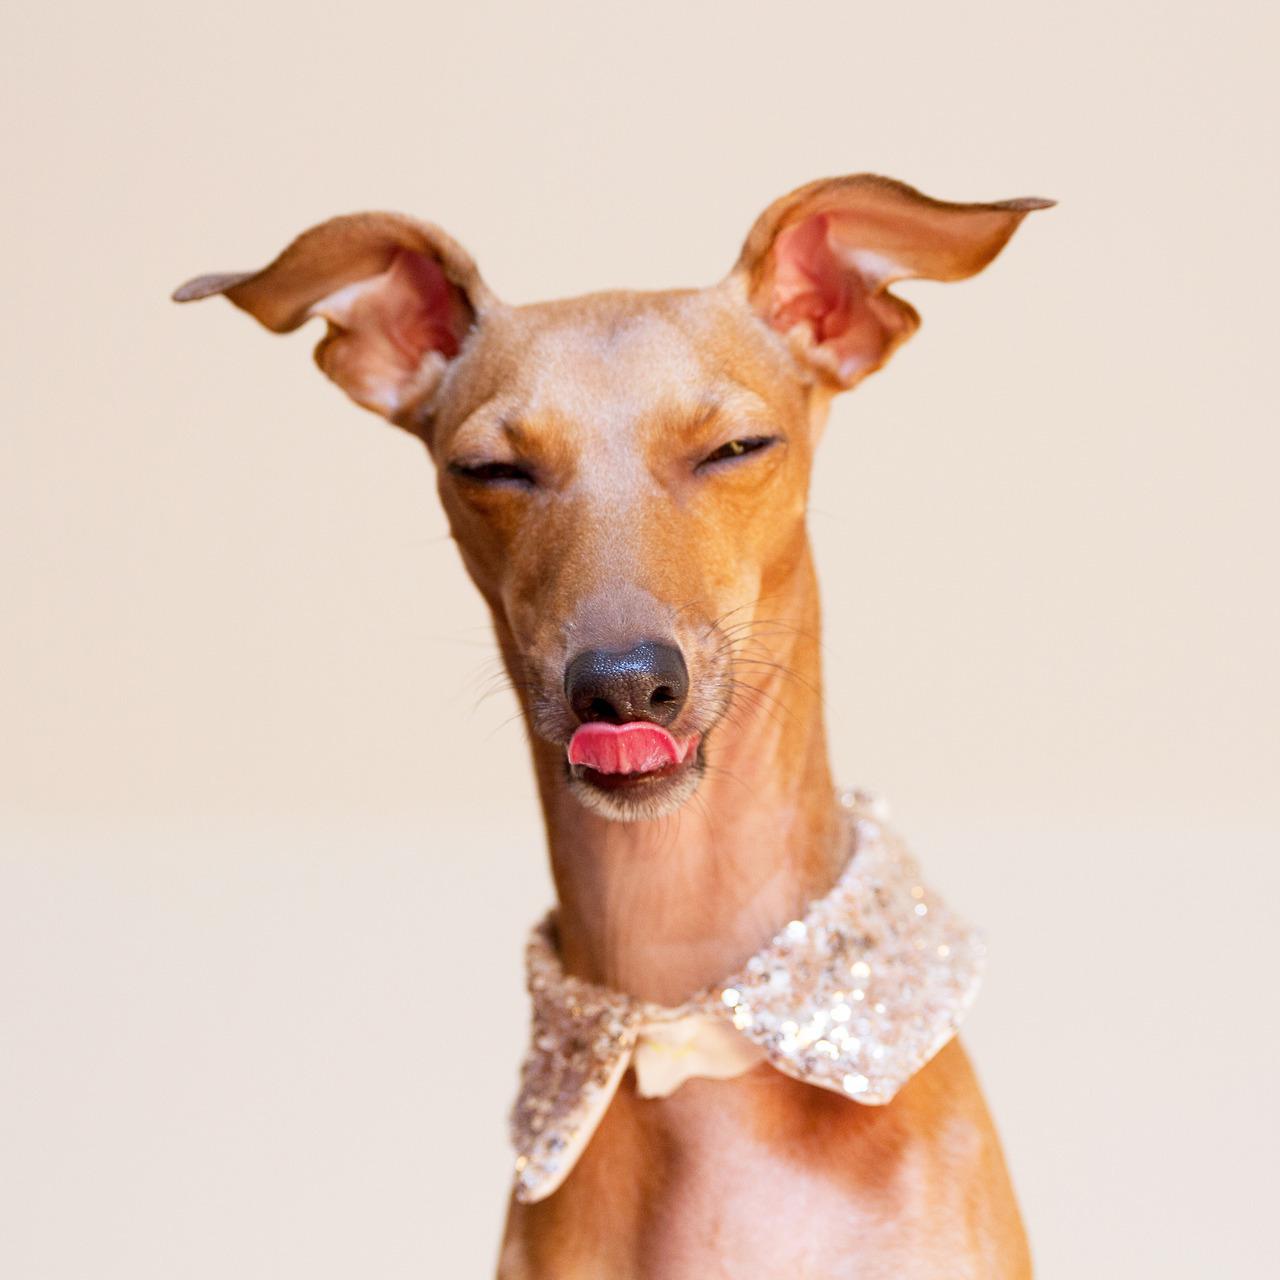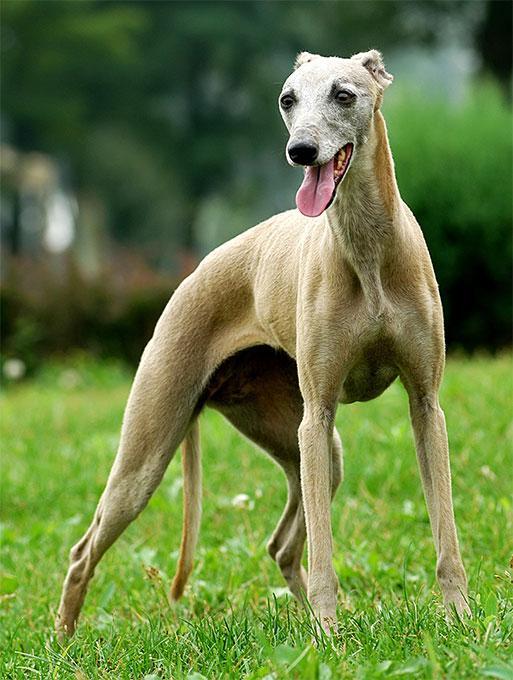The first image is the image on the left, the second image is the image on the right. For the images shown, is this caption "An image shows a dog with its tongue sticking out." true? Answer yes or no. Yes. The first image is the image on the left, the second image is the image on the right. For the images displayed, is the sentence "One of the dogs has a collar around its neck." factually correct? Answer yes or no. Yes. 